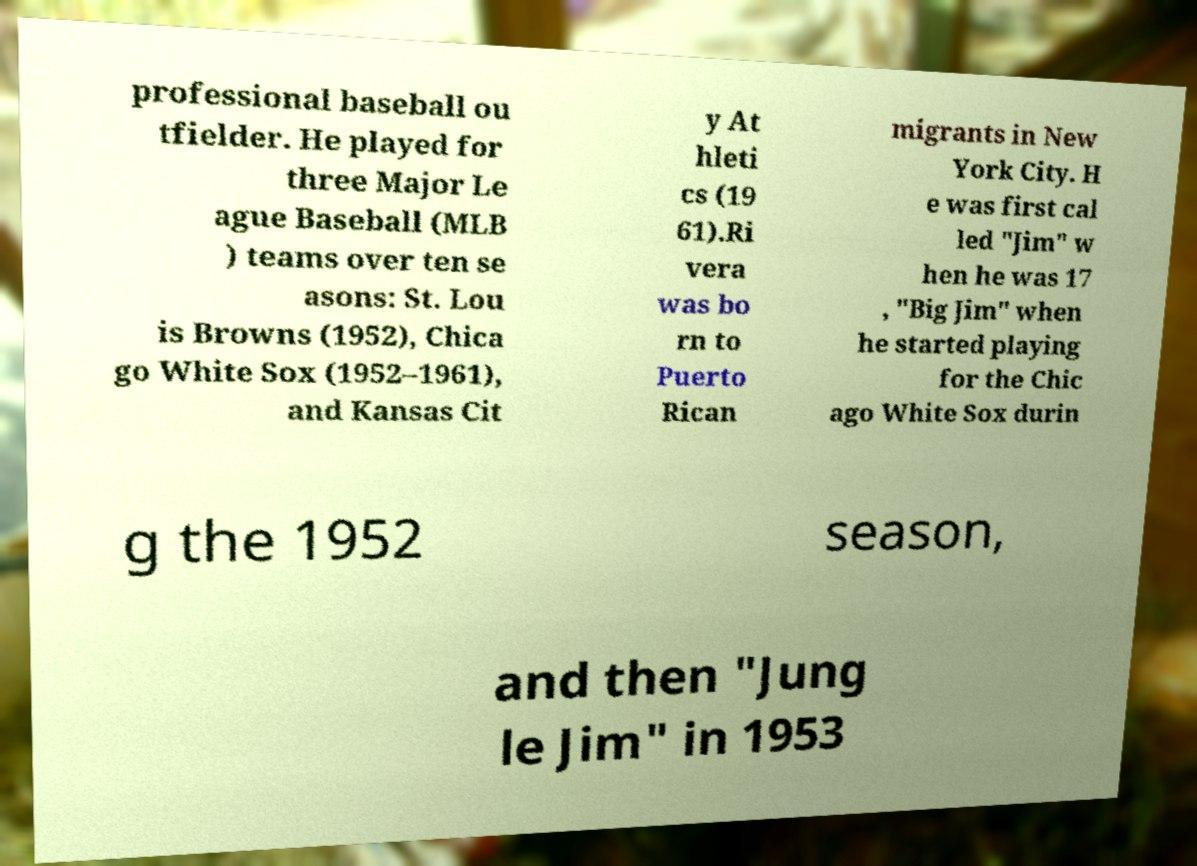For documentation purposes, I need the text within this image transcribed. Could you provide that? professional baseball ou tfielder. He played for three Major Le ague Baseball (MLB ) teams over ten se asons: St. Lou is Browns (1952), Chica go White Sox (1952–1961), and Kansas Cit y At hleti cs (19 61).Ri vera was bo rn to Puerto Rican migrants in New York City. H e was first cal led "Jim" w hen he was 17 , "Big Jim" when he started playing for the Chic ago White Sox durin g the 1952 season, and then "Jung le Jim" in 1953 